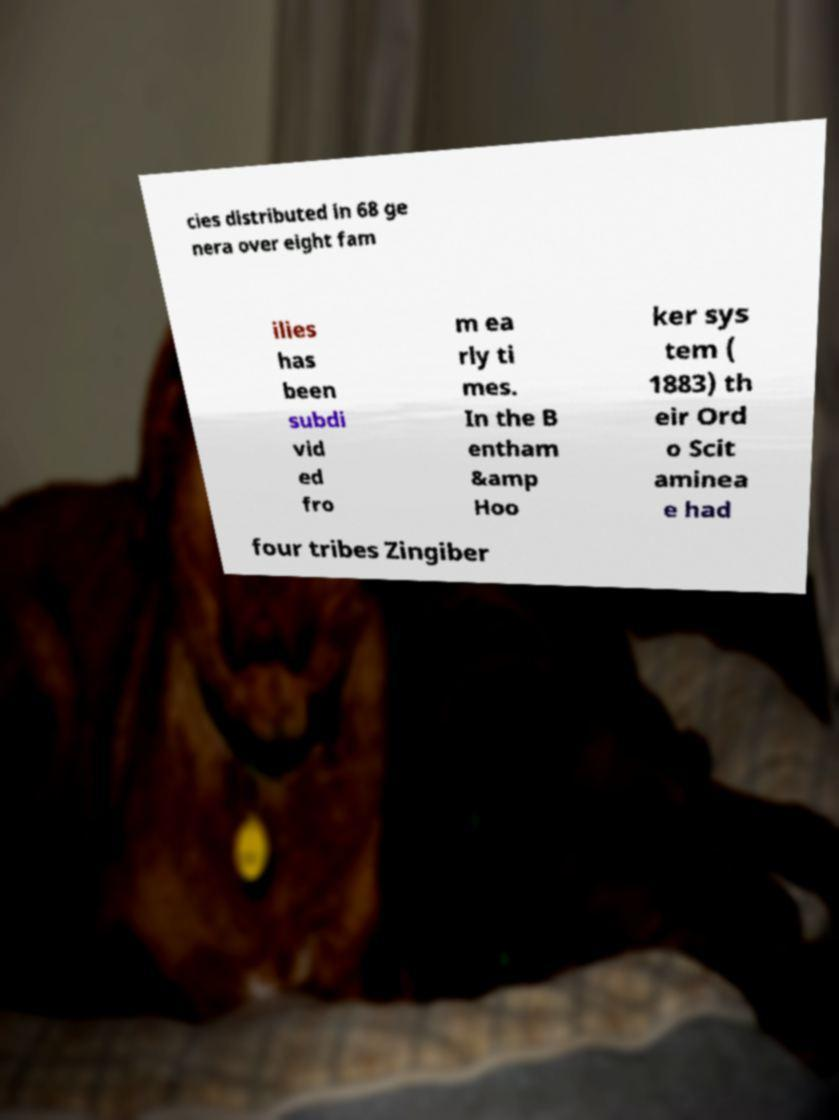Could you extract and type out the text from this image? cies distributed in 68 ge nera over eight fam ilies has been subdi vid ed fro m ea rly ti mes. In the B entham &amp Hoo ker sys tem ( 1883) th eir Ord o Scit aminea e had four tribes Zingiber 